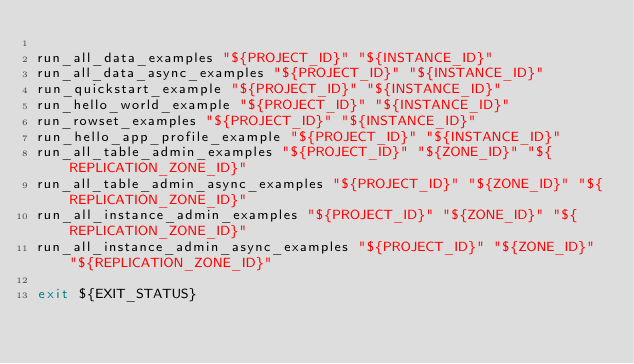<code> <loc_0><loc_0><loc_500><loc_500><_Bash_>
run_all_data_examples "${PROJECT_ID}" "${INSTANCE_ID}"
run_all_data_async_examples "${PROJECT_ID}" "${INSTANCE_ID}"
run_quickstart_example "${PROJECT_ID}" "${INSTANCE_ID}"
run_hello_world_example "${PROJECT_ID}" "${INSTANCE_ID}"
run_rowset_examples "${PROJECT_ID}" "${INSTANCE_ID}"
run_hello_app_profile_example "${PROJECT_ID}" "${INSTANCE_ID}"
run_all_table_admin_examples "${PROJECT_ID}" "${ZONE_ID}" "${REPLICATION_ZONE_ID}"
run_all_table_admin_async_examples "${PROJECT_ID}" "${ZONE_ID}" "${REPLICATION_ZONE_ID}"
run_all_instance_admin_examples "${PROJECT_ID}" "${ZONE_ID}" "${REPLICATION_ZONE_ID}"
run_all_instance_admin_async_examples "${PROJECT_ID}" "${ZONE_ID}" "${REPLICATION_ZONE_ID}"

exit ${EXIT_STATUS}
</code> 